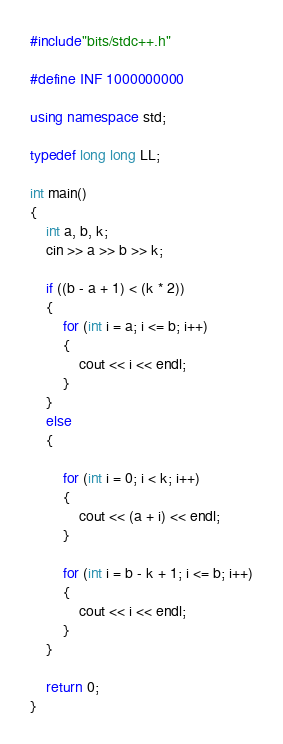Convert code to text. <code><loc_0><loc_0><loc_500><loc_500><_C++_>#include"bits/stdc++.h"

#define INF 1000000000

using namespace std;

typedef long long LL;

int main()
{
	int a, b, k;
	cin >> a >> b >> k;

	if ((b - a + 1) < (k * 2))
	{
		for (int i = a; i <= b; i++)
		{
			cout << i << endl;
		}
	}
	else
	{

		for (int i = 0; i < k; i++)
		{
			cout << (a + i) << endl;
		}

		for (int i = b - k + 1; i <= b; i++)
		{
			cout << i << endl;
		}
	}

	return 0;
}</code> 